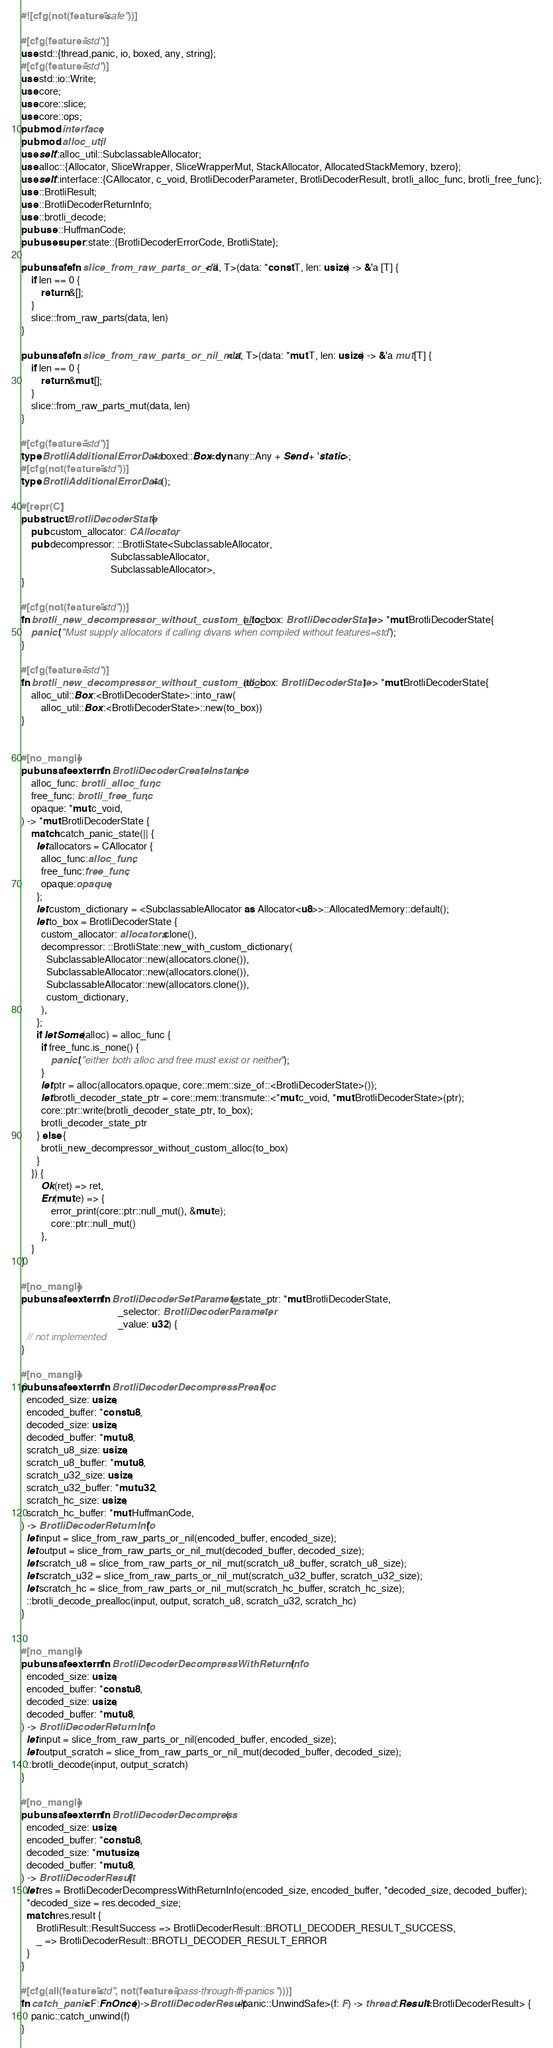Convert code to text. <code><loc_0><loc_0><loc_500><loc_500><_Rust_>#![cfg(not(feature="safe"))]

#[cfg(feature="std")]
use std::{thread,panic, io, boxed, any, string};
#[cfg(feature="std")]
use std::io::Write;
use core;
use core::slice;
use core::ops;
pub mod interface;
pub mod alloc_util;
use self::alloc_util::SubclassableAllocator;
use alloc::{Allocator, SliceWrapper, SliceWrapperMut, StackAllocator, AllocatedStackMemory, bzero};
use self::interface::{CAllocator, c_void, BrotliDecoderParameter, BrotliDecoderResult, brotli_alloc_func, brotli_free_func};
use ::BrotliResult;
use ::BrotliDecoderReturnInfo;
use ::brotli_decode;
pub use ::HuffmanCode;
pub use super::state::{BrotliDecoderErrorCode, BrotliState};

pub unsafe fn slice_from_raw_parts_or_nil<'a, T>(data: *const T, len: usize) -> &'a [T] {
    if len == 0 {
        return &[];
    }
    slice::from_raw_parts(data, len)
}

pub unsafe fn slice_from_raw_parts_or_nil_mut<'a, T>(data: *mut T, len: usize) -> &'a mut [T] {
    if len == 0 {
        return &mut [];
    }
    slice::from_raw_parts_mut(data, len)
}

#[cfg(feature="std")]
type BrotliAdditionalErrorData = boxed::Box<dyn any::Any + Send + 'static>;
#[cfg(not(feature="std"))]
type BrotliAdditionalErrorData = ();

#[repr(C)]
pub struct BrotliDecoderState {
    pub custom_allocator: CAllocator,
    pub decompressor: ::BrotliState<SubclassableAllocator,
                                    SubclassableAllocator,
                                    SubclassableAllocator>,
}

#[cfg(not(feature="std"))]
fn brotli_new_decompressor_without_custom_alloc(_to_box: BrotliDecoderState) -> *mut BrotliDecoderState{
    panic!("Must supply allocators if calling divans when compiled without features=std");
}

#[cfg(feature="std")]
fn brotli_new_decompressor_without_custom_alloc(to_box: BrotliDecoderState) -> *mut BrotliDecoderState{
    alloc_util::Box::<BrotliDecoderState>::into_raw(
        alloc_util::Box::<BrotliDecoderState>::new(to_box))
}


#[no_mangle]
pub unsafe extern fn BrotliDecoderCreateInstance(
    alloc_func: brotli_alloc_func,
    free_func: brotli_free_func,
    opaque: *mut c_void,
) -> *mut BrotliDecoderState {
    match catch_panic_state(|| {
      let allocators = CAllocator {
        alloc_func:alloc_func,
        free_func:free_func,
        opaque:opaque,
      };
      let custom_dictionary = <SubclassableAllocator as Allocator<u8>>::AllocatedMemory::default();
      let to_box = BrotliDecoderState {
        custom_allocator: allocators.clone(),
        decompressor: ::BrotliState::new_with_custom_dictionary(
          SubclassableAllocator::new(allocators.clone()),
          SubclassableAllocator::new(allocators.clone()),
          SubclassableAllocator::new(allocators.clone()),
          custom_dictionary,
        ),
      };
      if let Some(alloc) = alloc_func {
        if free_func.is_none() {
            panic!("either both alloc and free must exist or neither");
        }
        let ptr = alloc(allocators.opaque, core::mem::size_of::<BrotliDecoderState>());
        let brotli_decoder_state_ptr = core::mem::transmute::<*mut c_void, *mut BrotliDecoderState>(ptr);
        core::ptr::write(brotli_decoder_state_ptr, to_box);
        brotli_decoder_state_ptr
      } else {
        brotli_new_decompressor_without_custom_alloc(to_box)
      }
    }) {
        Ok(ret) => ret,
        Err(mut e) => {
            error_print(core::ptr::null_mut(), &mut e);
            core::ptr::null_mut()
        },
    }
}

#[no_mangle]
pub unsafe extern fn BrotliDecoderSetParameter(_state_ptr: *mut BrotliDecoderState,
                                       _selector: BrotliDecoderParameter,
                                       _value: u32) {
  // not implemented
}

#[no_mangle]
pub unsafe extern fn BrotliDecoderDecompressPrealloc(
  encoded_size: usize,
  encoded_buffer: *const u8,
  decoded_size: usize,
  decoded_buffer: *mut u8,
  scratch_u8_size: usize,
  scratch_u8_buffer: *mut u8,
  scratch_u32_size: usize,
  scratch_u32_buffer: *mut u32,
  scratch_hc_size: usize,
  scratch_hc_buffer: *mut HuffmanCode,
) -> BrotliDecoderReturnInfo {
  let input = slice_from_raw_parts_or_nil(encoded_buffer, encoded_size);
  let output = slice_from_raw_parts_or_nil_mut(decoded_buffer, decoded_size);
  let scratch_u8 = slice_from_raw_parts_or_nil_mut(scratch_u8_buffer, scratch_u8_size);
  let scratch_u32 = slice_from_raw_parts_or_nil_mut(scratch_u32_buffer, scratch_u32_size);
  let scratch_hc = slice_from_raw_parts_or_nil_mut(scratch_hc_buffer, scratch_hc_size);
  ::brotli_decode_prealloc(input, output, scratch_u8, scratch_u32, scratch_hc)
}


#[no_mangle]
pub unsafe extern fn BrotliDecoderDecompressWithReturnInfo(
  encoded_size: usize,
  encoded_buffer: *const u8,
  decoded_size: usize,
  decoded_buffer: *mut u8,
) -> BrotliDecoderReturnInfo {
  let input = slice_from_raw_parts_or_nil(encoded_buffer, encoded_size);
  let output_scratch = slice_from_raw_parts_or_nil_mut(decoded_buffer, decoded_size);
  ::brotli_decode(input, output_scratch)
}

#[no_mangle]
pub unsafe extern fn BrotliDecoderDecompress(
  encoded_size: usize,
  encoded_buffer: *const u8,
  decoded_size: *mut usize,
  decoded_buffer: *mut u8,
) -> BrotliDecoderResult {
  let res = BrotliDecoderDecompressWithReturnInfo(encoded_size, encoded_buffer, *decoded_size, decoded_buffer);
  *decoded_size = res.decoded_size;  
  match res.result {
      BrotliResult::ResultSuccess => BrotliDecoderResult::BROTLI_DECODER_RESULT_SUCCESS,
      _ => BrotliDecoderResult::BROTLI_DECODER_RESULT_ERROR
  }
}

#[cfg(all(feature="std", not(feature="pass-through-ffi-panics")))]
fn catch_panic<F:FnOnce()->BrotliDecoderResult+panic::UnwindSafe>(f: F) -> thread::Result<BrotliDecoderResult> {
    panic::catch_unwind(f)
}
</code> 